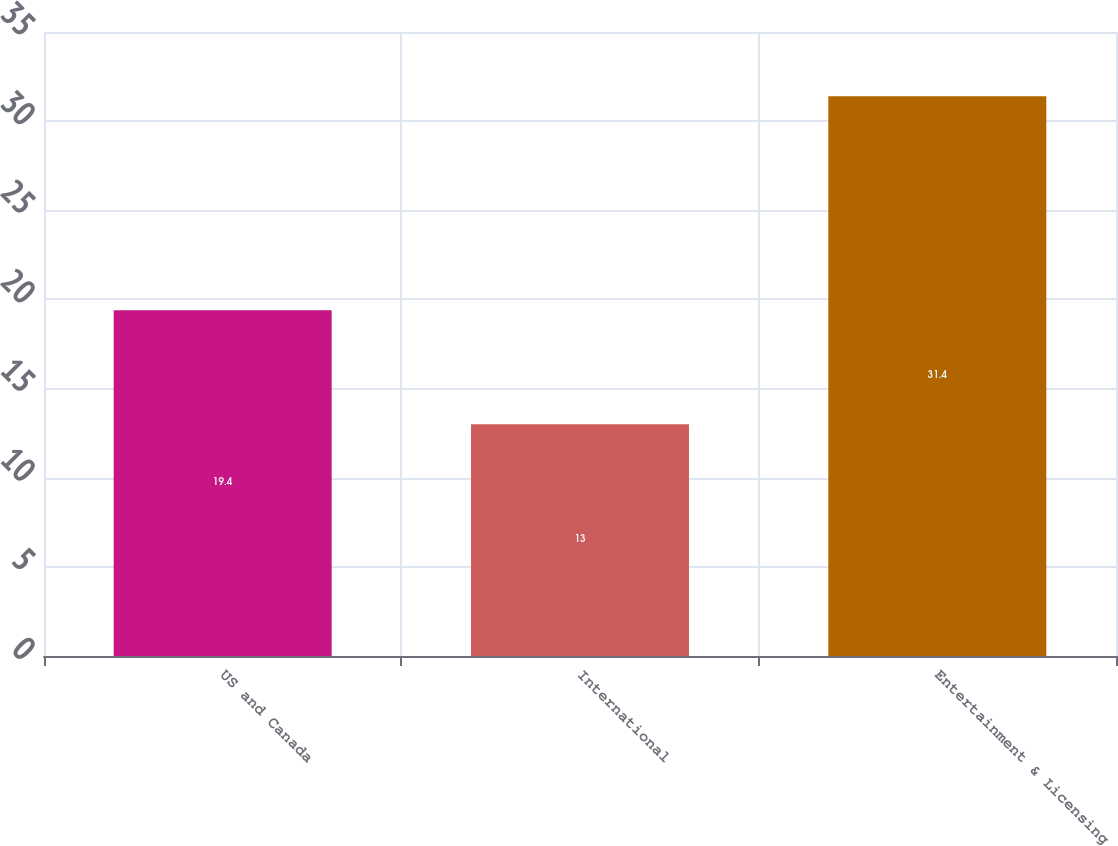Convert chart to OTSL. <chart><loc_0><loc_0><loc_500><loc_500><bar_chart><fcel>US and Canada<fcel>International<fcel>Entertainment & Licensing<nl><fcel>19.4<fcel>13<fcel>31.4<nl></chart> 